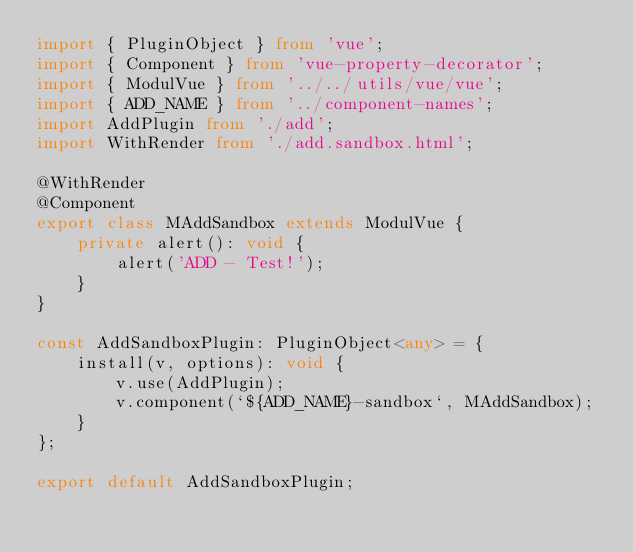<code> <loc_0><loc_0><loc_500><loc_500><_TypeScript_>import { PluginObject } from 'vue';
import { Component } from 'vue-property-decorator';
import { ModulVue } from '../../utils/vue/vue';
import { ADD_NAME } from '../component-names';
import AddPlugin from './add';
import WithRender from './add.sandbox.html';

@WithRender
@Component
export class MAddSandbox extends ModulVue {
    private alert(): void {
        alert('ADD - Test!');
    }
}

const AddSandboxPlugin: PluginObject<any> = {
    install(v, options): void {
        v.use(AddPlugin);
        v.component(`${ADD_NAME}-sandbox`, MAddSandbox);
    }
};

export default AddSandboxPlugin;
</code> 